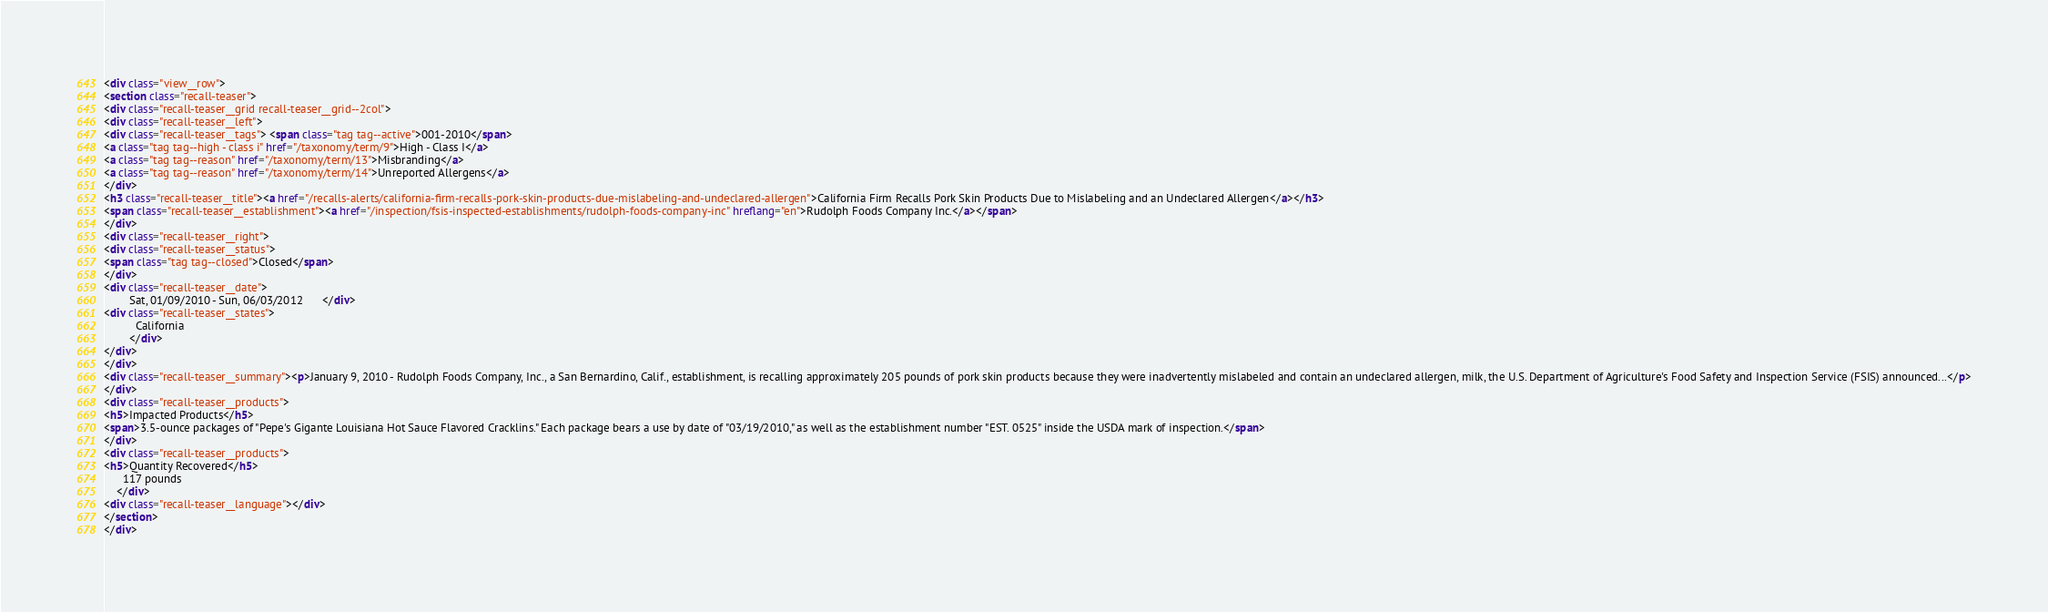Convert code to text. <code><loc_0><loc_0><loc_500><loc_500><_HTML_><div class="view__row">
<section class="recall-teaser">
<div class="recall-teaser__grid recall-teaser__grid--2col">
<div class="recall-teaser__left">
<div class="recall-teaser__tags"> <span class="tag tag--active">001-2010</span>
<a class="tag tag--high - class i" href="/taxonomy/term/9">High - Class I</a>
<a class="tag tag--reason" href="/taxonomy/term/13">Misbranding</a>
<a class="tag tag--reason" href="/taxonomy/term/14">Unreported Allergens</a>
</div>
<h3 class="recall-teaser__title"><a href="/recalls-alerts/california-firm-recalls-pork-skin-products-due-mislabeling-and-undeclared-allergen">California Firm Recalls Pork Skin Products Due to Mislabeling and an Undeclared Allergen</a></h3>
<span class="recall-teaser__establishment"><a href="/inspection/fsis-inspected-establishments/rudolph-foods-company-inc" hreflang="en">Rudolph Foods Company Inc.</a></span>
</div>
<div class="recall-teaser__right">
<div class="recall-teaser__status">
<span class="tag tag--closed">Closed</span>
</div>
<div class="recall-teaser__date">
        Sat, 01/09/2010 - Sun, 06/03/2012      </div>
<div class="recall-teaser__states">
          California
        </div>
</div>
</div>
<div class="recall-teaser__summary"><p>January 9, 2010 - Rudolph Foods Company, Inc., a San Bernardino, Calif., establishment, is recalling approximately 205 pounds of pork skin products because they were inadvertently mislabeled and contain an undeclared allergen, milk, the U.S. Department of Agriculture's Food Safety and Inspection Service (FSIS) announced...</p>
</div>
<div class="recall-teaser__products">
<h5>Impacted Products</h5>
<span>3.5-ounce packages of "Pepe's Gigante Louisiana Hot Sauce Flavored Cracklins." Each package bears a use by date of "03/19/2010," as well as the establishment number "EST. 0525" inside the USDA mark of inspection.</span>
</div>
<div class="recall-teaser__products">
<h5>Quantity Recovered</h5>
      117 pounds
    </div>
<div class="recall-teaser__language"></div>
</section>
</div></code> 